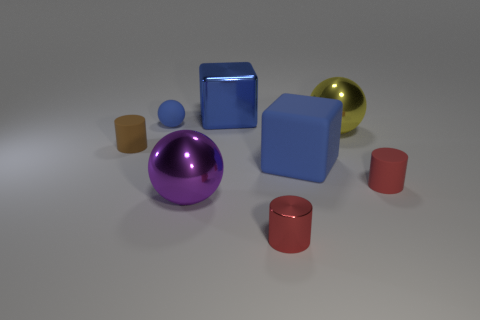There is a blue rubber thing in front of the blue ball; is it the same size as the matte ball?
Your response must be concise. No. What size is the blue thing that is right of the large purple sphere and behind the blue rubber block?
Make the answer very short. Large. What material is the other tiny object that is the same color as the small shiny thing?
Offer a very short reply. Rubber. What number of large things have the same color as the tiny metallic cylinder?
Provide a short and direct response. 0. Is the number of large rubber objects that are left of the large metal block the same as the number of small metallic objects?
Give a very brief answer. No. What is the color of the metal cylinder?
Give a very brief answer. Red. The purple ball that is made of the same material as the yellow thing is what size?
Provide a short and direct response. Large. There is another big ball that is the same material as the yellow ball; what is its color?
Offer a very short reply. Purple. Is there a blue shiny thing of the same size as the brown object?
Give a very brief answer. No. There is a brown object that is the same shape as the red rubber object; what is its material?
Offer a terse response. Rubber. 